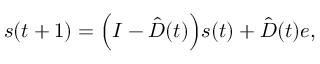<formula> <loc_0><loc_0><loc_500><loc_500>s ( t + 1 ) = \left ( I - \hat { D } ( t ) \right ) s ( t ) + \hat { D } ( t ) e ,</formula> 